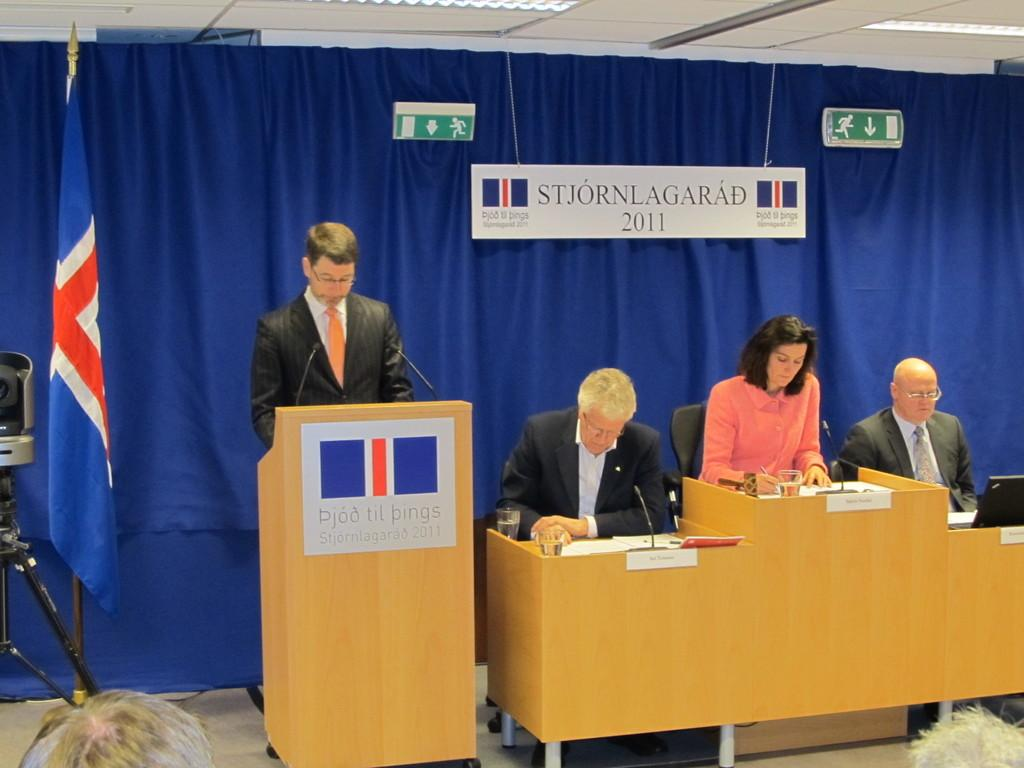Provide a one-sentence caption for the provided image. a group of speakers with signage saying STJORNLAGARAD 2011 in back of them and on the higher speaker stand as well. 